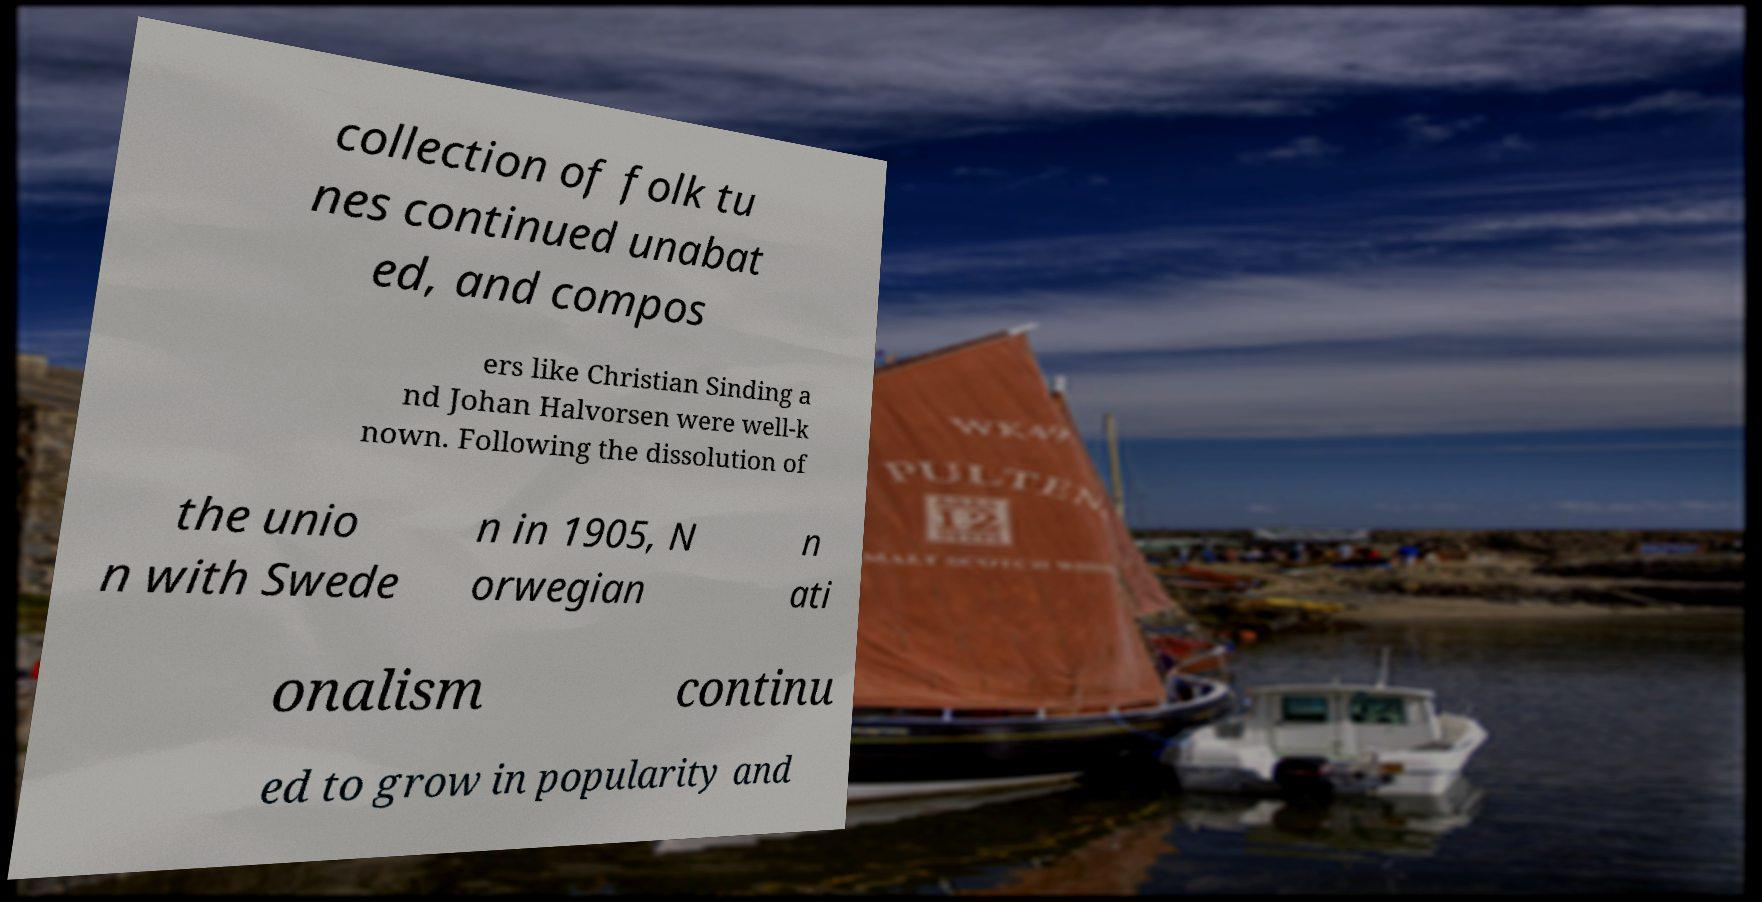Could you assist in decoding the text presented in this image and type it out clearly? collection of folk tu nes continued unabat ed, and compos ers like Christian Sinding a nd Johan Halvorsen were well-k nown. Following the dissolution of the unio n with Swede n in 1905, N orwegian n ati onalism continu ed to grow in popularity and 